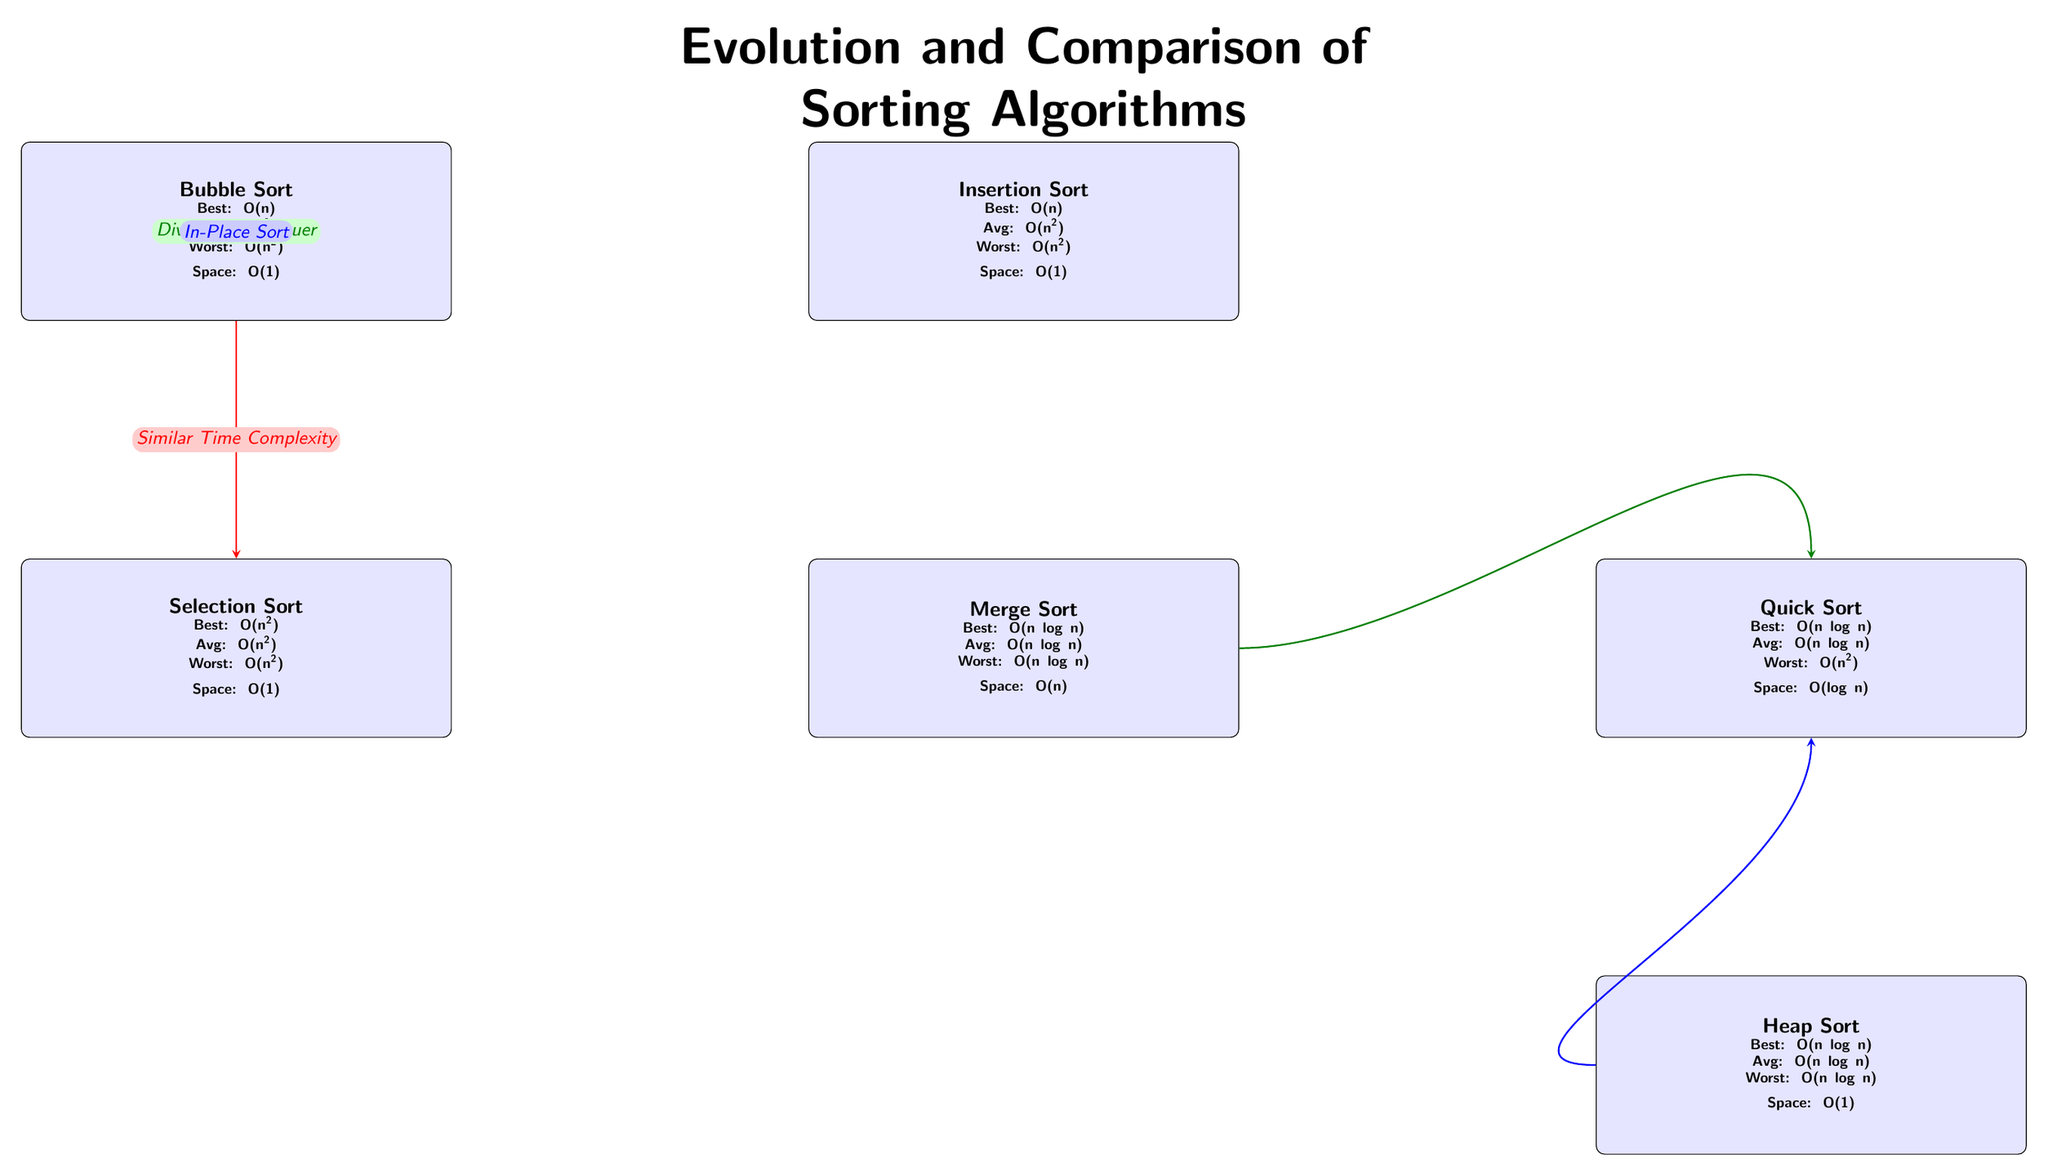What is the worst-case time complexity of Bubble Sort? The diagram lists the worst-case time complexity of Bubble Sort as O(n^2). This value can be found directly under Bubble Sort in the node.
Answer: O(n^2) How many sorting algorithms are represented in the diagram? The diagram shows a total of six sorting algorithms: Bubble Sort, Selection Sort, Insertion Sort, Merge Sort, Quick Sort, and Heap Sort. This count can be derived by counting the number of algorithm nodes present.
Answer: 6 What type of sorting algorithm is Merge Sort classified as? The diagram states that Merge Sort uses a "Divide and Conquer" approach, indicated by the labeled arrow leading towards Quick Sort. This label directly identifies its classification.
Answer: Divide and Conquer What is the average-case time complexity of Quick Sort? The average-case time complexity of Quick Sort is listed as O(n log n) in the diagram, shown directly in the Quick Sort node.
Answer: O(n log n) Which sorting algorithms have the same worst-case time complexity? By examining the diagram, both Merge Sort and Heap Sort have the same worst-case time complexity of O(n log n), as evident in their respective nodes.
Answer: Merge Sort, Heap Sort Which sorting algorithm requires O(1) space complexity? In the diagram, both Bubble Sort, Selection Sort, and Heap Sort are noted to have O(1) space complexity. This information can be found in the respective algorithm nodes.
Answer: Bubble Sort, Selection Sort, Heap Sort What is the connection between Merge Sort and Quick Sort? The diagram indicates a connection marked by a green arrow with the label "Divide and Conquer" between Merge Sort and Quick Sort, showcasing that both utilize this methodology.
Answer: Divide and Conquer What sorting algorithm has the best-case time complexity of O(n)? The diagram shows that both Bubble Sort and Insertion Sort have a best-case time complexity of O(n). This is reflected in the specific values indicated in their nodes.
Answer: Bubble Sort, Insertion Sort What is the relationship between Heap Sort and Quick Sort? The diagram shows a blue arrow pointing from Heap Sort to Quick Sort, labeled "In-Place Sort," indicating that both are characterized by being in-place sorting algorithms.
Answer: In-Place Sort 